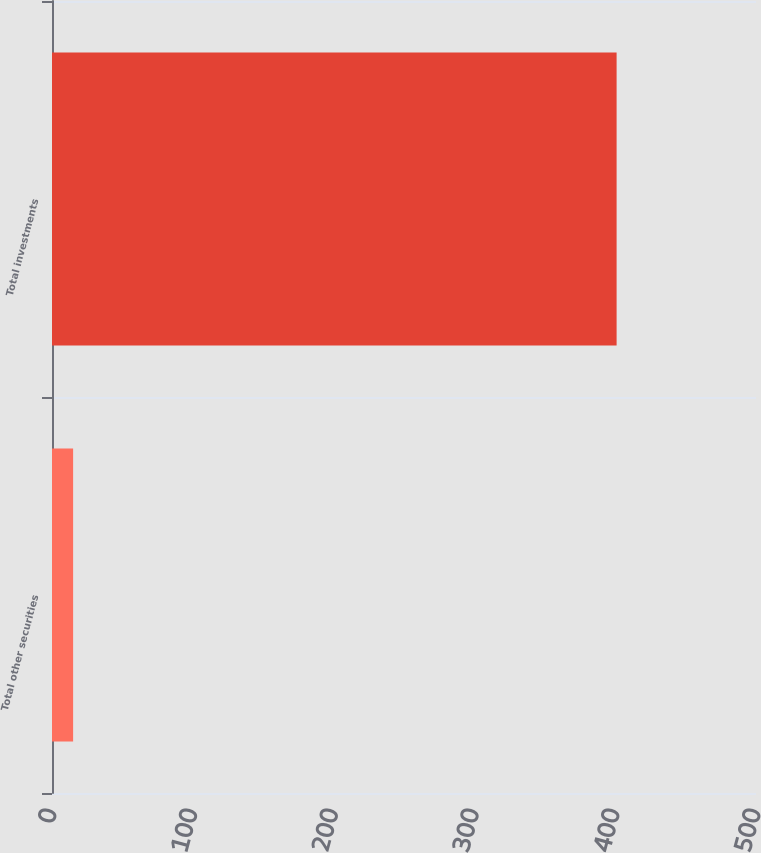<chart> <loc_0><loc_0><loc_500><loc_500><bar_chart><fcel>Total other securities<fcel>Total investments<nl><fcel>15<fcel>401<nl></chart> 